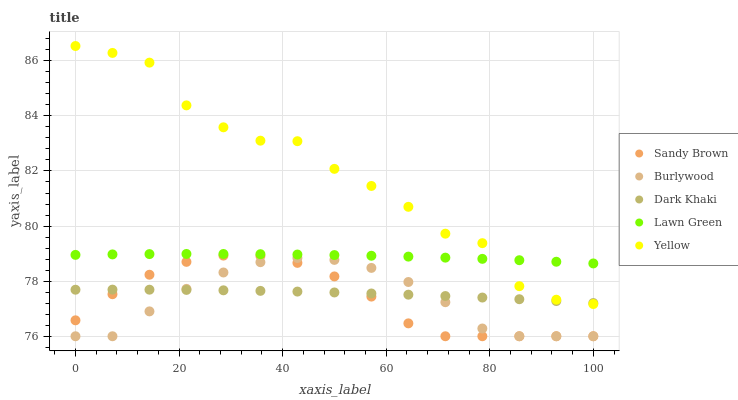Does Burlywood have the minimum area under the curve?
Answer yes or no. Yes. Does Yellow have the maximum area under the curve?
Answer yes or no. Yes. Does Dark Khaki have the minimum area under the curve?
Answer yes or no. No. Does Dark Khaki have the maximum area under the curve?
Answer yes or no. No. Is Dark Khaki the smoothest?
Answer yes or no. Yes. Is Yellow the roughest?
Answer yes or no. Yes. Is Sandy Brown the smoothest?
Answer yes or no. No. Is Sandy Brown the roughest?
Answer yes or no. No. Does Burlywood have the lowest value?
Answer yes or no. Yes. Does Dark Khaki have the lowest value?
Answer yes or no. No. Does Yellow have the highest value?
Answer yes or no. Yes. Does Sandy Brown have the highest value?
Answer yes or no. No. Is Burlywood less than Yellow?
Answer yes or no. Yes. Is Yellow greater than Sandy Brown?
Answer yes or no. Yes. Does Lawn Green intersect Yellow?
Answer yes or no. Yes. Is Lawn Green less than Yellow?
Answer yes or no. No. Is Lawn Green greater than Yellow?
Answer yes or no. No. Does Burlywood intersect Yellow?
Answer yes or no. No. 